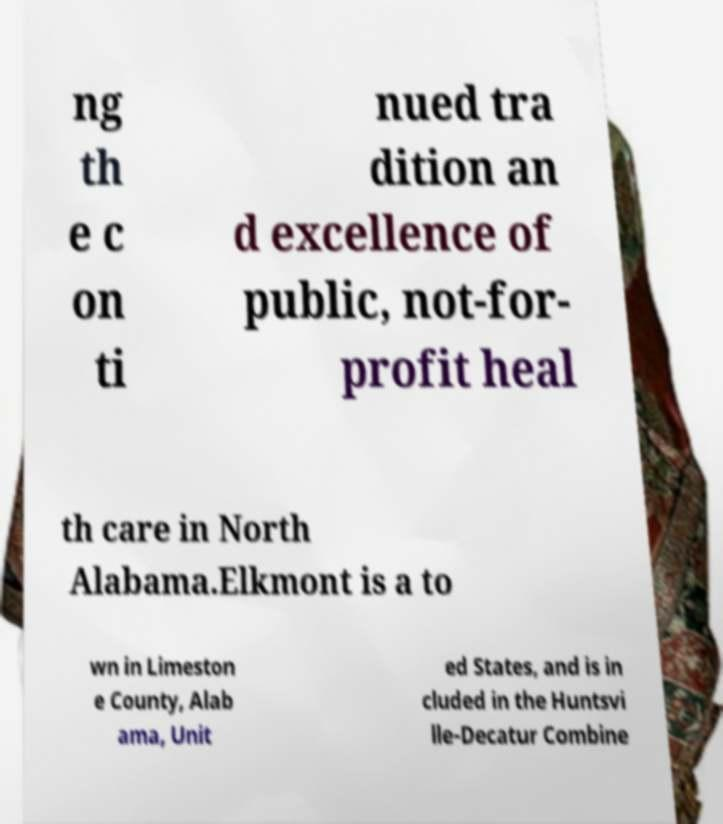For documentation purposes, I need the text within this image transcribed. Could you provide that? ng th e c on ti nued tra dition an d excellence of public, not-for- profit heal th care in North Alabama.Elkmont is a to wn in Limeston e County, Alab ama, Unit ed States, and is in cluded in the Huntsvi lle-Decatur Combine 